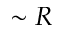<formula> <loc_0><loc_0><loc_500><loc_500>\sim R</formula> 